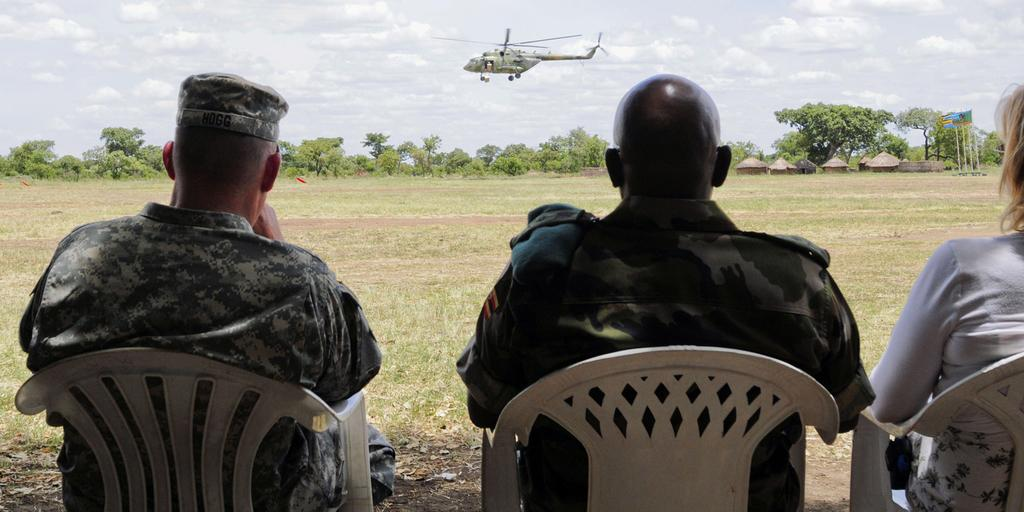What are the people in the image doing? The people in the image are sitting on chairs. What can be seen in the background of the image? There are trees, huts, and flags in the background of the image. What is located at the top of the image? There is an aeroplane at the top of the image. What is visible in the sky in the image? There are clouds in the sky. How many kittens are playing in the wilderness in the image? There are no kittens or wilderness present in the image. 